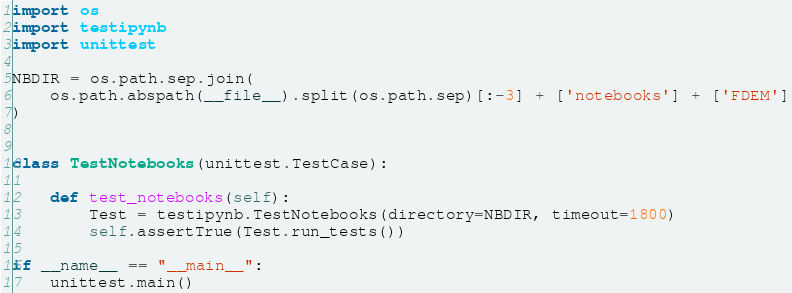<code> <loc_0><loc_0><loc_500><loc_500><_Python_>import os
import testipynb
import unittest

NBDIR = os.path.sep.join(
    os.path.abspath(__file__).split(os.path.sep)[:-3] + ['notebooks'] + ['FDEM']
)


class TestNotebooks(unittest.TestCase):

    def test_notebooks(self):
        Test = testipynb.TestNotebooks(directory=NBDIR, timeout=1800)
        self.assertTrue(Test.run_tests())

if __name__ == "__main__":
    unittest.main()
</code> 